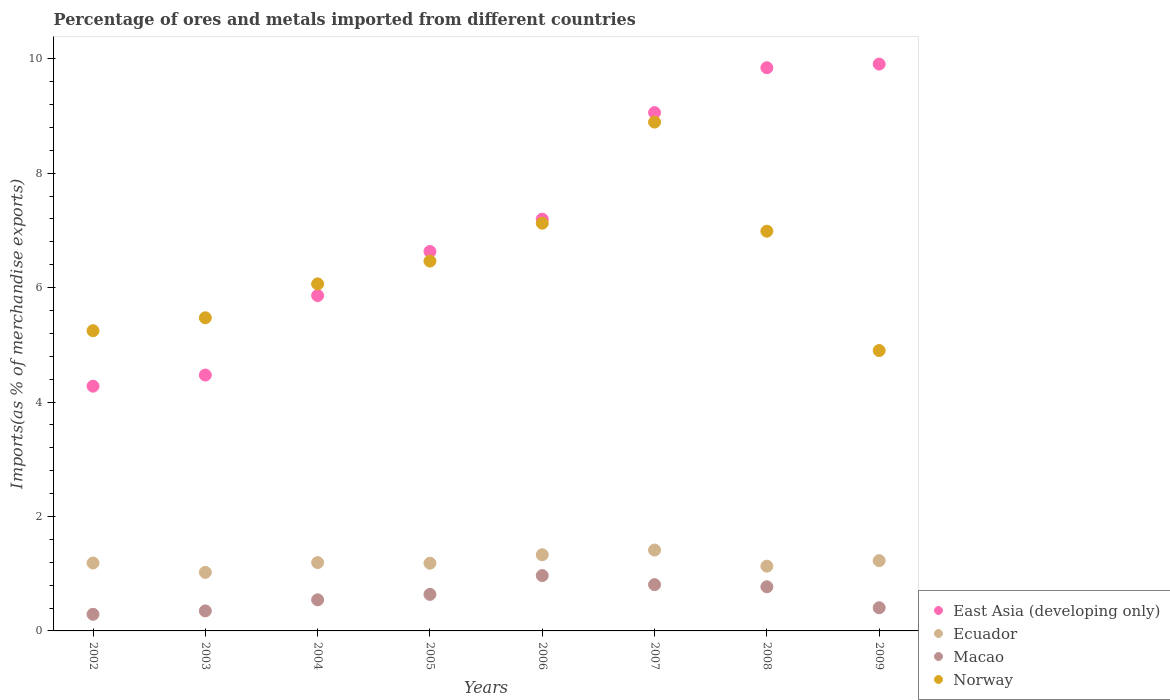Is the number of dotlines equal to the number of legend labels?
Offer a very short reply. Yes. What is the percentage of imports to different countries in East Asia (developing only) in 2009?
Keep it short and to the point. 9.91. Across all years, what is the maximum percentage of imports to different countries in East Asia (developing only)?
Your response must be concise. 9.91. Across all years, what is the minimum percentage of imports to different countries in Ecuador?
Provide a succinct answer. 1.02. What is the total percentage of imports to different countries in Macao in the graph?
Your answer should be very brief. 4.78. What is the difference between the percentage of imports to different countries in Macao in 2003 and that in 2006?
Provide a succinct answer. -0.62. What is the difference between the percentage of imports to different countries in Macao in 2005 and the percentage of imports to different countries in Ecuador in 2008?
Offer a very short reply. -0.49. What is the average percentage of imports to different countries in Ecuador per year?
Give a very brief answer. 1.21. In the year 2005, what is the difference between the percentage of imports to different countries in Norway and percentage of imports to different countries in Ecuador?
Make the answer very short. 5.28. What is the ratio of the percentage of imports to different countries in East Asia (developing only) in 2003 to that in 2006?
Offer a terse response. 0.62. Is the difference between the percentage of imports to different countries in Norway in 2003 and 2009 greater than the difference between the percentage of imports to different countries in Ecuador in 2003 and 2009?
Make the answer very short. Yes. What is the difference between the highest and the second highest percentage of imports to different countries in Ecuador?
Provide a succinct answer. 0.08. What is the difference between the highest and the lowest percentage of imports to different countries in Macao?
Your response must be concise. 0.68. In how many years, is the percentage of imports to different countries in East Asia (developing only) greater than the average percentage of imports to different countries in East Asia (developing only) taken over all years?
Make the answer very short. 4. Is the sum of the percentage of imports to different countries in Norway in 2003 and 2009 greater than the maximum percentage of imports to different countries in Macao across all years?
Provide a succinct answer. Yes. Is it the case that in every year, the sum of the percentage of imports to different countries in Ecuador and percentage of imports to different countries in East Asia (developing only)  is greater than the sum of percentage of imports to different countries in Macao and percentage of imports to different countries in Norway?
Offer a very short reply. Yes. Is it the case that in every year, the sum of the percentage of imports to different countries in East Asia (developing only) and percentage of imports to different countries in Macao  is greater than the percentage of imports to different countries in Norway?
Give a very brief answer. No. How many dotlines are there?
Your answer should be compact. 4. How many years are there in the graph?
Your answer should be compact. 8. Are the values on the major ticks of Y-axis written in scientific E-notation?
Provide a short and direct response. No. How are the legend labels stacked?
Your answer should be very brief. Vertical. What is the title of the graph?
Offer a terse response. Percentage of ores and metals imported from different countries. What is the label or title of the X-axis?
Provide a succinct answer. Years. What is the label or title of the Y-axis?
Offer a very short reply. Imports(as % of merchandise exports). What is the Imports(as % of merchandise exports) of East Asia (developing only) in 2002?
Your answer should be compact. 4.28. What is the Imports(as % of merchandise exports) in Ecuador in 2002?
Ensure brevity in your answer.  1.19. What is the Imports(as % of merchandise exports) in Macao in 2002?
Keep it short and to the point. 0.29. What is the Imports(as % of merchandise exports) in Norway in 2002?
Ensure brevity in your answer.  5.25. What is the Imports(as % of merchandise exports) in East Asia (developing only) in 2003?
Give a very brief answer. 4.47. What is the Imports(as % of merchandise exports) of Ecuador in 2003?
Make the answer very short. 1.02. What is the Imports(as % of merchandise exports) in Macao in 2003?
Your answer should be very brief. 0.35. What is the Imports(as % of merchandise exports) in Norway in 2003?
Ensure brevity in your answer.  5.47. What is the Imports(as % of merchandise exports) in East Asia (developing only) in 2004?
Your answer should be very brief. 5.86. What is the Imports(as % of merchandise exports) in Ecuador in 2004?
Offer a terse response. 1.19. What is the Imports(as % of merchandise exports) of Macao in 2004?
Your response must be concise. 0.54. What is the Imports(as % of merchandise exports) of Norway in 2004?
Offer a very short reply. 6.07. What is the Imports(as % of merchandise exports) in East Asia (developing only) in 2005?
Offer a terse response. 6.63. What is the Imports(as % of merchandise exports) of Ecuador in 2005?
Ensure brevity in your answer.  1.18. What is the Imports(as % of merchandise exports) of Macao in 2005?
Offer a very short reply. 0.64. What is the Imports(as % of merchandise exports) in Norway in 2005?
Ensure brevity in your answer.  6.46. What is the Imports(as % of merchandise exports) in East Asia (developing only) in 2006?
Make the answer very short. 7.2. What is the Imports(as % of merchandise exports) of Ecuador in 2006?
Provide a short and direct response. 1.33. What is the Imports(as % of merchandise exports) in Macao in 2006?
Your response must be concise. 0.97. What is the Imports(as % of merchandise exports) of Norway in 2006?
Give a very brief answer. 7.13. What is the Imports(as % of merchandise exports) of East Asia (developing only) in 2007?
Ensure brevity in your answer.  9.06. What is the Imports(as % of merchandise exports) of Ecuador in 2007?
Provide a short and direct response. 1.41. What is the Imports(as % of merchandise exports) of Macao in 2007?
Offer a very short reply. 0.81. What is the Imports(as % of merchandise exports) in Norway in 2007?
Make the answer very short. 8.89. What is the Imports(as % of merchandise exports) in East Asia (developing only) in 2008?
Make the answer very short. 9.84. What is the Imports(as % of merchandise exports) of Ecuador in 2008?
Your answer should be very brief. 1.13. What is the Imports(as % of merchandise exports) in Macao in 2008?
Ensure brevity in your answer.  0.77. What is the Imports(as % of merchandise exports) in Norway in 2008?
Ensure brevity in your answer.  6.99. What is the Imports(as % of merchandise exports) in East Asia (developing only) in 2009?
Your response must be concise. 9.91. What is the Imports(as % of merchandise exports) of Ecuador in 2009?
Your answer should be very brief. 1.23. What is the Imports(as % of merchandise exports) of Macao in 2009?
Provide a short and direct response. 0.4. What is the Imports(as % of merchandise exports) in Norway in 2009?
Keep it short and to the point. 4.9. Across all years, what is the maximum Imports(as % of merchandise exports) of East Asia (developing only)?
Your response must be concise. 9.91. Across all years, what is the maximum Imports(as % of merchandise exports) of Ecuador?
Provide a short and direct response. 1.41. Across all years, what is the maximum Imports(as % of merchandise exports) in Macao?
Make the answer very short. 0.97. Across all years, what is the maximum Imports(as % of merchandise exports) in Norway?
Your answer should be very brief. 8.89. Across all years, what is the minimum Imports(as % of merchandise exports) in East Asia (developing only)?
Ensure brevity in your answer.  4.28. Across all years, what is the minimum Imports(as % of merchandise exports) of Ecuador?
Keep it short and to the point. 1.02. Across all years, what is the minimum Imports(as % of merchandise exports) of Macao?
Make the answer very short. 0.29. Across all years, what is the minimum Imports(as % of merchandise exports) of Norway?
Provide a short and direct response. 4.9. What is the total Imports(as % of merchandise exports) in East Asia (developing only) in the graph?
Ensure brevity in your answer.  57.25. What is the total Imports(as % of merchandise exports) in Ecuador in the graph?
Offer a terse response. 9.69. What is the total Imports(as % of merchandise exports) in Macao in the graph?
Keep it short and to the point. 4.78. What is the total Imports(as % of merchandise exports) in Norway in the graph?
Your answer should be compact. 51.16. What is the difference between the Imports(as % of merchandise exports) of East Asia (developing only) in 2002 and that in 2003?
Your answer should be compact. -0.19. What is the difference between the Imports(as % of merchandise exports) of Ecuador in 2002 and that in 2003?
Your response must be concise. 0.16. What is the difference between the Imports(as % of merchandise exports) of Macao in 2002 and that in 2003?
Ensure brevity in your answer.  -0.06. What is the difference between the Imports(as % of merchandise exports) of Norway in 2002 and that in 2003?
Your answer should be compact. -0.23. What is the difference between the Imports(as % of merchandise exports) in East Asia (developing only) in 2002 and that in 2004?
Offer a terse response. -1.58. What is the difference between the Imports(as % of merchandise exports) of Ecuador in 2002 and that in 2004?
Give a very brief answer. -0.01. What is the difference between the Imports(as % of merchandise exports) in Macao in 2002 and that in 2004?
Offer a very short reply. -0.25. What is the difference between the Imports(as % of merchandise exports) of Norway in 2002 and that in 2004?
Your response must be concise. -0.82. What is the difference between the Imports(as % of merchandise exports) in East Asia (developing only) in 2002 and that in 2005?
Make the answer very short. -2.35. What is the difference between the Imports(as % of merchandise exports) in Ecuador in 2002 and that in 2005?
Make the answer very short. 0. What is the difference between the Imports(as % of merchandise exports) in Macao in 2002 and that in 2005?
Give a very brief answer. -0.35. What is the difference between the Imports(as % of merchandise exports) of Norway in 2002 and that in 2005?
Offer a terse response. -1.22. What is the difference between the Imports(as % of merchandise exports) of East Asia (developing only) in 2002 and that in 2006?
Your answer should be very brief. -2.92. What is the difference between the Imports(as % of merchandise exports) of Ecuador in 2002 and that in 2006?
Make the answer very short. -0.14. What is the difference between the Imports(as % of merchandise exports) of Macao in 2002 and that in 2006?
Your response must be concise. -0.68. What is the difference between the Imports(as % of merchandise exports) in Norway in 2002 and that in 2006?
Your response must be concise. -1.88. What is the difference between the Imports(as % of merchandise exports) of East Asia (developing only) in 2002 and that in 2007?
Offer a terse response. -4.78. What is the difference between the Imports(as % of merchandise exports) in Ecuador in 2002 and that in 2007?
Your response must be concise. -0.23. What is the difference between the Imports(as % of merchandise exports) in Macao in 2002 and that in 2007?
Keep it short and to the point. -0.52. What is the difference between the Imports(as % of merchandise exports) in Norway in 2002 and that in 2007?
Make the answer very short. -3.65. What is the difference between the Imports(as % of merchandise exports) of East Asia (developing only) in 2002 and that in 2008?
Provide a succinct answer. -5.57. What is the difference between the Imports(as % of merchandise exports) of Ecuador in 2002 and that in 2008?
Give a very brief answer. 0.06. What is the difference between the Imports(as % of merchandise exports) in Macao in 2002 and that in 2008?
Offer a very short reply. -0.48. What is the difference between the Imports(as % of merchandise exports) in Norway in 2002 and that in 2008?
Offer a terse response. -1.74. What is the difference between the Imports(as % of merchandise exports) in East Asia (developing only) in 2002 and that in 2009?
Your answer should be very brief. -5.63. What is the difference between the Imports(as % of merchandise exports) of Ecuador in 2002 and that in 2009?
Offer a very short reply. -0.04. What is the difference between the Imports(as % of merchandise exports) of Macao in 2002 and that in 2009?
Your response must be concise. -0.11. What is the difference between the Imports(as % of merchandise exports) of Norway in 2002 and that in 2009?
Provide a short and direct response. 0.35. What is the difference between the Imports(as % of merchandise exports) of East Asia (developing only) in 2003 and that in 2004?
Provide a succinct answer. -1.39. What is the difference between the Imports(as % of merchandise exports) in Ecuador in 2003 and that in 2004?
Provide a succinct answer. -0.17. What is the difference between the Imports(as % of merchandise exports) in Macao in 2003 and that in 2004?
Make the answer very short. -0.19. What is the difference between the Imports(as % of merchandise exports) in Norway in 2003 and that in 2004?
Your answer should be very brief. -0.59. What is the difference between the Imports(as % of merchandise exports) in East Asia (developing only) in 2003 and that in 2005?
Provide a short and direct response. -2.16. What is the difference between the Imports(as % of merchandise exports) in Ecuador in 2003 and that in 2005?
Your answer should be compact. -0.16. What is the difference between the Imports(as % of merchandise exports) in Macao in 2003 and that in 2005?
Provide a short and direct response. -0.29. What is the difference between the Imports(as % of merchandise exports) in Norway in 2003 and that in 2005?
Provide a succinct answer. -0.99. What is the difference between the Imports(as % of merchandise exports) of East Asia (developing only) in 2003 and that in 2006?
Make the answer very short. -2.72. What is the difference between the Imports(as % of merchandise exports) of Ecuador in 2003 and that in 2006?
Your answer should be compact. -0.31. What is the difference between the Imports(as % of merchandise exports) of Macao in 2003 and that in 2006?
Your answer should be compact. -0.62. What is the difference between the Imports(as % of merchandise exports) of Norway in 2003 and that in 2006?
Your answer should be compact. -1.65. What is the difference between the Imports(as % of merchandise exports) of East Asia (developing only) in 2003 and that in 2007?
Provide a succinct answer. -4.59. What is the difference between the Imports(as % of merchandise exports) of Ecuador in 2003 and that in 2007?
Your answer should be very brief. -0.39. What is the difference between the Imports(as % of merchandise exports) of Macao in 2003 and that in 2007?
Provide a short and direct response. -0.46. What is the difference between the Imports(as % of merchandise exports) in Norway in 2003 and that in 2007?
Give a very brief answer. -3.42. What is the difference between the Imports(as % of merchandise exports) in East Asia (developing only) in 2003 and that in 2008?
Offer a terse response. -5.37. What is the difference between the Imports(as % of merchandise exports) in Ecuador in 2003 and that in 2008?
Your answer should be very brief. -0.11. What is the difference between the Imports(as % of merchandise exports) in Macao in 2003 and that in 2008?
Keep it short and to the point. -0.42. What is the difference between the Imports(as % of merchandise exports) of Norway in 2003 and that in 2008?
Offer a terse response. -1.51. What is the difference between the Imports(as % of merchandise exports) in East Asia (developing only) in 2003 and that in 2009?
Offer a very short reply. -5.43. What is the difference between the Imports(as % of merchandise exports) in Ecuador in 2003 and that in 2009?
Your answer should be compact. -0.2. What is the difference between the Imports(as % of merchandise exports) in Macao in 2003 and that in 2009?
Offer a terse response. -0.06. What is the difference between the Imports(as % of merchandise exports) of Norway in 2003 and that in 2009?
Provide a succinct answer. 0.57. What is the difference between the Imports(as % of merchandise exports) in East Asia (developing only) in 2004 and that in 2005?
Give a very brief answer. -0.77. What is the difference between the Imports(as % of merchandise exports) in Ecuador in 2004 and that in 2005?
Your answer should be very brief. 0.01. What is the difference between the Imports(as % of merchandise exports) of Macao in 2004 and that in 2005?
Your answer should be very brief. -0.1. What is the difference between the Imports(as % of merchandise exports) of Norway in 2004 and that in 2005?
Give a very brief answer. -0.4. What is the difference between the Imports(as % of merchandise exports) in East Asia (developing only) in 2004 and that in 2006?
Offer a very short reply. -1.34. What is the difference between the Imports(as % of merchandise exports) in Ecuador in 2004 and that in 2006?
Offer a very short reply. -0.14. What is the difference between the Imports(as % of merchandise exports) of Macao in 2004 and that in 2006?
Make the answer very short. -0.42. What is the difference between the Imports(as % of merchandise exports) in Norway in 2004 and that in 2006?
Give a very brief answer. -1.06. What is the difference between the Imports(as % of merchandise exports) of East Asia (developing only) in 2004 and that in 2007?
Your answer should be very brief. -3.2. What is the difference between the Imports(as % of merchandise exports) in Ecuador in 2004 and that in 2007?
Your answer should be compact. -0.22. What is the difference between the Imports(as % of merchandise exports) in Macao in 2004 and that in 2007?
Offer a terse response. -0.27. What is the difference between the Imports(as % of merchandise exports) in Norway in 2004 and that in 2007?
Ensure brevity in your answer.  -2.83. What is the difference between the Imports(as % of merchandise exports) of East Asia (developing only) in 2004 and that in 2008?
Your answer should be very brief. -3.98. What is the difference between the Imports(as % of merchandise exports) of Ecuador in 2004 and that in 2008?
Provide a succinct answer. 0.06. What is the difference between the Imports(as % of merchandise exports) in Macao in 2004 and that in 2008?
Make the answer very short. -0.23. What is the difference between the Imports(as % of merchandise exports) of Norway in 2004 and that in 2008?
Ensure brevity in your answer.  -0.92. What is the difference between the Imports(as % of merchandise exports) of East Asia (developing only) in 2004 and that in 2009?
Make the answer very short. -4.05. What is the difference between the Imports(as % of merchandise exports) in Ecuador in 2004 and that in 2009?
Make the answer very short. -0.03. What is the difference between the Imports(as % of merchandise exports) in Macao in 2004 and that in 2009?
Your answer should be very brief. 0.14. What is the difference between the Imports(as % of merchandise exports) in Norway in 2004 and that in 2009?
Give a very brief answer. 1.16. What is the difference between the Imports(as % of merchandise exports) of East Asia (developing only) in 2005 and that in 2006?
Offer a very short reply. -0.56. What is the difference between the Imports(as % of merchandise exports) in Ecuador in 2005 and that in 2006?
Your answer should be compact. -0.15. What is the difference between the Imports(as % of merchandise exports) in Macao in 2005 and that in 2006?
Ensure brevity in your answer.  -0.33. What is the difference between the Imports(as % of merchandise exports) of Norway in 2005 and that in 2006?
Offer a very short reply. -0.66. What is the difference between the Imports(as % of merchandise exports) in East Asia (developing only) in 2005 and that in 2007?
Provide a succinct answer. -2.43. What is the difference between the Imports(as % of merchandise exports) in Ecuador in 2005 and that in 2007?
Offer a terse response. -0.23. What is the difference between the Imports(as % of merchandise exports) in Macao in 2005 and that in 2007?
Offer a very short reply. -0.17. What is the difference between the Imports(as % of merchandise exports) of Norway in 2005 and that in 2007?
Make the answer very short. -2.43. What is the difference between the Imports(as % of merchandise exports) in East Asia (developing only) in 2005 and that in 2008?
Make the answer very short. -3.21. What is the difference between the Imports(as % of merchandise exports) in Ecuador in 2005 and that in 2008?
Your answer should be very brief. 0.05. What is the difference between the Imports(as % of merchandise exports) in Macao in 2005 and that in 2008?
Provide a short and direct response. -0.13. What is the difference between the Imports(as % of merchandise exports) of Norway in 2005 and that in 2008?
Offer a terse response. -0.52. What is the difference between the Imports(as % of merchandise exports) in East Asia (developing only) in 2005 and that in 2009?
Your response must be concise. -3.28. What is the difference between the Imports(as % of merchandise exports) of Ecuador in 2005 and that in 2009?
Provide a succinct answer. -0.04. What is the difference between the Imports(as % of merchandise exports) of Macao in 2005 and that in 2009?
Keep it short and to the point. 0.23. What is the difference between the Imports(as % of merchandise exports) in Norway in 2005 and that in 2009?
Give a very brief answer. 1.56. What is the difference between the Imports(as % of merchandise exports) of East Asia (developing only) in 2006 and that in 2007?
Keep it short and to the point. -1.86. What is the difference between the Imports(as % of merchandise exports) in Ecuador in 2006 and that in 2007?
Provide a succinct answer. -0.08. What is the difference between the Imports(as % of merchandise exports) in Macao in 2006 and that in 2007?
Your answer should be compact. 0.16. What is the difference between the Imports(as % of merchandise exports) in Norway in 2006 and that in 2007?
Offer a terse response. -1.77. What is the difference between the Imports(as % of merchandise exports) in East Asia (developing only) in 2006 and that in 2008?
Give a very brief answer. -2.65. What is the difference between the Imports(as % of merchandise exports) in Ecuador in 2006 and that in 2008?
Your answer should be very brief. 0.2. What is the difference between the Imports(as % of merchandise exports) in Macao in 2006 and that in 2008?
Offer a terse response. 0.2. What is the difference between the Imports(as % of merchandise exports) in Norway in 2006 and that in 2008?
Your response must be concise. 0.14. What is the difference between the Imports(as % of merchandise exports) in East Asia (developing only) in 2006 and that in 2009?
Provide a short and direct response. -2.71. What is the difference between the Imports(as % of merchandise exports) in Ecuador in 2006 and that in 2009?
Your answer should be very brief. 0.1. What is the difference between the Imports(as % of merchandise exports) of Macao in 2006 and that in 2009?
Provide a short and direct response. 0.56. What is the difference between the Imports(as % of merchandise exports) of Norway in 2006 and that in 2009?
Ensure brevity in your answer.  2.23. What is the difference between the Imports(as % of merchandise exports) in East Asia (developing only) in 2007 and that in 2008?
Provide a short and direct response. -0.78. What is the difference between the Imports(as % of merchandise exports) in Ecuador in 2007 and that in 2008?
Make the answer very short. 0.28. What is the difference between the Imports(as % of merchandise exports) of Macao in 2007 and that in 2008?
Your answer should be compact. 0.04. What is the difference between the Imports(as % of merchandise exports) of Norway in 2007 and that in 2008?
Offer a very short reply. 1.91. What is the difference between the Imports(as % of merchandise exports) in East Asia (developing only) in 2007 and that in 2009?
Your answer should be compact. -0.85. What is the difference between the Imports(as % of merchandise exports) in Ecuador in 2007 and that in 2009?
Offer a very short reply. 0.19. What is the difference between the Imports(as % of merchandise exports) of Macao in 2007 and that in 2009?
Your answer should be compact. 0.4. What is the difference between the Imports(as % of merchandise exports) of Norway in 2007 and that in 2009?
Provide a succinct answer. 3.99. What is the difference between the Imports(as % of merchandise exports) of East Asia (developing only) in 2008 and that in 2009?
Offer a very short reply. -0.06. What is the difference between the Imports(as % of merchandise exports) in Ecuador in 2008 and that in 2009?
Provide a succinct answer. -0.1. What is the difference between the Imports(as % of merchandise exports) in Macao in 2008 and that in 2009?
Your answer should be compact. 0.37. What is the difference between the Imports(as % of merchandise exports) in Norway in 2008 and that in 2009?
Offer a very short reply. 2.09. What is the difference between the Imports(as % of merchandise exports) of East Asia (developing only) in 2002 and the Imports(as % of merchandise exports) of Ecuador in 2003?
Give a very brief answer. 3.25. What is the difference between the Imports(as % of merchandise exports) of East Asia (developing only) in 2002 and the Imports(as % of merchandise exports) of Macao in 2003?
Give a very brief answer. 3.93. What is the difference between the Imports(as % of merchandise exports) in East Asia (developing only) in 2002 and the Imports(as % of merchandise exports) in Norway in 2003?
Offer a very short reply. -1.2. What is the difference between the Imports(as % of merchandise exports) in Ecuador in 2002 and the Imports(as % of merchandise exports) in Macao in 2003?
Give a very brief answer. 0.84. What is the difference between the Imports(as % of merchandise exports) of Ecuador in 2002 and the Imports(as % of merchandise exports) of Norway in 2003?
Your answer should be very brief. -4.29. What is the difference between the Imports(as % of merchandise exports) of Macao in 2002 and the Imports(as % of merchandise exports) of Norway in 2003?
Offer a very short reply. -5.18. What is the difference between the Imports(as % of merchandise exports) in East Asia (developing only) in 2002 and the Imports(as % of merchandise exports) in Ecuador in 2004?
Your response must be concise. 3.08. What is the difference between the Imports(as % of merchandise exports) in East Asia (developing only) in 2002 and the Imports(as % of merchandise exports) in Macao in 2004?
Make the answer very short. 3.73. What is the difference between the Imports(as % of merchandise exports) in East Asia (developing only) in 2002 and the Imports(as % of merchandise exports) in Norway in 2004?
Make the answer very short. -1.79. What is the difference between the Imports(as % of merchandise exports) in Ecuador in 2002 and the Imports(as % of merchandise exports) in Macao in 2004?
Provide a short and direct response. 0.64. What is the difference between the Imports(as % of merchandise exports) in Ecuador in 2002 and the Imports(as % of merchandise exports) in Norway in 2004?
Provide a short and direct response. -4.88. What is the difference between the Imports(as % of merchandise exports) in Macao in 2002 and the Imports(as % of merchandise exports) in Norway in 2004?
Keep it short and to the point. -5.77. What is the difference between the Imports(as % of merchandise exports) of East Asia (developing only) in 2002 and the Imports(as % of merchandise exports) of Ecuador in 2005?
Your answer should be very brief. 3.09. What is the difference between the Imports(as % of merchandise exports) in East Asia (developing only) in 2002 and the Imports(as % of merchandise exports) in Macao in 2005?
Your answer should be compact. 3.64. What is the difference between the Imports(as % of merchandise exports) of East Asia (developing only) in 2002 and the Imports(as % of merchandise exports) of Norway in 2005?
Your answer should be very brief. -2.19. What is the difference between the Imports(as % of merchandise exports) of Ecuador in 2002 and the Imports(as % of merchandise exports) of Macao in 2005?
Provide a short and direct response. 0.55. What is the difference between the Imports(as % of merchandise exports) of Ecuador in 2002 and the Imports(as % of merchandise exports) of Norway in 2005?
Make the answer very short. -5.28. What is the difference between the Imports(as % of merchandise exports) of Macao in 2002 and the Imports(as % of merchandise exports) of Norway in 2005?
Provide a short and direct response. -6.17. What is the difference between the Imports(as % of merchandise exports) in East Asia (developing only) in 2002 and the Imports(as % of merchandise exports) in Ecuador in 2006?
Your answer should be compact. 2.95. What is the difference between the Imports(as % of merchandise exports) in East Asia (developing only) in 2002 and the Imports(as % of merchandise exports) in Macao in 2006?
Offer a very short reply. 3.31. What is the difference between the Imports(as % of merchandise exports) in East Asia (developing only) in 2002 and the Imports(as % of merchandise exports) in Norway in 2006?
Provide a succinct answer. -2.85. What is the difference between the Imports(as % of merchandise exports) of Ecuador in 2002 and the Imports(as % of merchandise exports) of Macao in 2006?
Your answer should be very brief. 0.22. What is the difference between the Imports(as % of merchandise exports) in Ecuador in 2002 and the Imports(as % of merchandise exports) in Norway in 2006?
Ensure brevity in your answer.  -5.94. What is the difference between the Imports(as % of merchandise exports) of Macao in 2002 and the Imports(as % of merchandise exports) of Norway in 2006?
Provide a short and direct response. -6.84. What is the difference between the Imports(as % of merchandise exports) in East Asia (developing only) in 2002 and the Imports(as % of merchandise exports) in Ecuador in 2007?
Ensure brevity in your answer.  2.86. What is the difference between the Imports(as % of merchandise exports) of East Asia (developing only) in 2002 and the Imports(as % of merchandise exports) of Macao in 2007?
Your answer should be very brief. 3.47. What is the difference between the Imports(as % of merchandise exports) of East Asia (developing only) in 2002 and the Imports(as % of merchandise exports) of Norway in 2007?
Keep it short and to the point. -4.62. What is the difference between the Imports(as % of merchandise exports) of Ecuador in 2002 and the Imports(as % of merchandise exports) of Macao in 2007?
Offer a terse response. 0.38. What is the difference between the Imports(as % of merchandise exports) of Ecuador in 2002 and the Imports(as % of merchandise exports) of Norway in 2007?
Keep it short and to the point. -7.71. What is the difference between the Imports(as % of merchandise exports) of Macao in 2002 and the Imports(as % of merchandise exports) of Norway in 2007?
Your answer should be compact. -8.6. What is the difference between the Imports(as % of merchandise exports) of East Asia (developing only) in 2002 and the Imports(as % of merchandise exports) of Ecuador in 2008?
Offer a terse response. 3.15. What is the difference between the Imports(as % of merchandise exports) in East Asia (developing only) in 2002 and the Imports(as % of merchandise exports) in Macao in 2008?
Make the answer very short. 3.51. What is the difference between the Imports(as % of merchandise exports) of East Asia (developing only) in 2002 and the Imports(as % of merchandise exports) of Norway in 2008?
Provide a short and direct response. -2.71. What is the difference between the Imports(as % of merchandise exports) in Ecuador in 2002 and the Imports(as % of merchandise exports) in Macao in 2008?
Keep it short and to the point. 0.42. What is the difference between the Imports(as % of merchandise exports) in Ecuador in 2002 and the Imports(as % of merchandise exports) in Norway in 2008?
Your answer should be very brief. -5.8. What is the difference between the Imports(as % of merchandise exports) in Macao in 2002 and the Imports(as % of merchandise exports) in Norway in 2008?
Make the answer very short. -6.7. What is the difference between the Imports(as % of merchandise exports) in East Asia (developing only) in 2002 and the Imports(as % of merchandise exports) in Ecuador in 2009?
Your answer should be very brief. 3.05. What is the difference between the Imports(as % of merchandise exports) of East Asia (developing only) in 2002 and the Imports(as % of merchandise exports) of Macao in 2009?
Your answer should be compact. 3.87. What is the difference between the Imports(as % of merchandise exports) of East Asia (developing only) in 2002 and the Imports(as % of merchandise exports) of Norway in 2009?
Your answer should be compact. -0.62. What is the difference between the Imports(as % of merchandise exports) in Ecuador in 2002 and the Imports(as % of merchandise exports) in Macao in 2009?
Provide a succinct answer. 0.78. What is the difference between the Imports(as % of merchandise exports) of Ecuador in 2002 and the Imports(as % of merchandise exports) of Norway in 2009?
Ensure brevity in your answer.  -3.71. What is the difference between the Imports(as % of merchandise exports) in Macao in 2002 and the Imports(as % of merchandise exports) in Norway in 2009?
Offer a very short reply. -4.61. What is the difference between the Imports(as % of merchandise exports) of East Asia (developing only) in 2003 and the Imports(as % of merchandise exports) of Ecuador in 2004?
Give a very brief answer. 3.28. What is the difference between the Imports(as % of merchandise exports) in East Asia (developing only) in 2003 and the Imports(as % of merchandise exports) in Macao in 2004?
Keep it short and to the point. 3.93. What is the difference between the Imports(as % of merchandise exports) in East Asia (developing only) in 2003 and the Imports(as % of merchandise exports) in Norway in 2004?
Give a very brief answer. -1.59. What is the difference between the Imports(as % of merchandise exports) in Ecuador in 2003 and the Imports(as % of merchandise exports) in Macao in 2004?
Your answer should be compact. 0.48. What is the difference between the Imports(as % of merchandise exports) in Ecuador in 2003 and the Imports(as % of merchandise exports) in Norway in 2004?
Offer a terse response. -5.04. What is the difference between the Imports(as % of merchandise exports) of Macao in 2003 and the Imports(as % of merchandise exports) of Norway in 2004?
Provide a short and direct response. -5.72. What is the difference between the Imports(as % of merchandise exports) in East Asia (developing only) in 2003 and the Imports(as % of merchandise exports) in Ecuador in 2005?
Keep it short and to the point. 3.29. What is the difference between the Imports(as % of merchandise exports) of East Asia (developing only) in 2003 and the Imports(as % of merchandise exports) of Macao in 2005?
Make the answer very short. 3.83. What is the difference between the Imports(as % of merchandise exports) of East Asia (developing only) in 2003 and the Imports(as % of merchandise exports) of Norway in 2005?
Provide a succinct answer. -1.99. What is the difference between the Imports(as % of merchandise exports) of Ecuador in 2003 and the Imports(as % of merchandise exports) of Macao in 2005?
Give a very brief answer. 0.38. What is the difference between the Imports(as % of merchandise exports) of Ecuador in 2003 and the Imports(as % of merchandise exports) of Norway in 2005?
Provide a short and direct response. -5.44. What is the difference between the Imports(as % of merchandise exports) in Macao in 2003 and the Imports(as % of merchandise exports) in Norway in 2005?
Your answer should be compact. -6.11. What is the difference between the Imports(as % of merchandise exports) of East Asia (developing only) in 2003 and the Imports(as % of merchandise exports) of Ecuador in 2006?
Your answer should be compact. 3.14. What is the difference between the Imports(as % of merchandise exports) in East Asia (developing only) in 2003 and the Imports(as % of merchandise exports) in Macao in 2006?
Ensure brevity in your answer.  3.5. What is the difference between the Imports(as % of merchandise exports) in East Asia (developing only) in 2003 and the Imports(as % of merchandise exports) in Norway in 2006?
Your answer should be compact. -2.65. What is the difference between the Imports(as % of merchandise exports) in Ecuador in 2003 and the Imports(as % of merchandise exports) in Macao in 2006?
Keep it short and to the point. 0.06. What is the difference between the Imports(as % of merchandise exports) in Ecuador in 2003 and the Imports(as % of merchandise exports) in Norway in 2006?
Make the answer very short. -6.1. What is the difference between the Imports(as % of merchandise exports) in Macao in 2003 and the Imports(as % of merchandise exports) in Norway in 2006?
Keep it short and to the point. -6.78. What is the difference between the Imports(as % of merchandise exports) of East Asia (developing only) in 2003 and the Imports(as % of merchandise exports) of Ecuador in 2007?
Offer a terse response. 3.06. What is the difference between the Imports(as % of merchandise exports) of East Asia (developing only) in 2003 and the Imports(as % of merchandise exports) of Macao in 2007?
Provide a succinct answer. 3.66. What is the difference between the Imports(as % of merchandise exports) in East Asia (developing only) in 2003 and the Imports(as % of merchandise exports) in Norway in 2007?
Ensure brevity in your answer.  -4.42. What is the difference between the Imports(as % of merchandise exports) in Ecuador in 2003 and the Imports(as % of merchandise exports) in Macao in 2007?
Your answer should be compact. 0.21. What is the difference between the Imports(as % of merchandise exports) in Ecuador in 2003 and the Imports(as % of merchandise exports) in Norway in 2007?
Provide a short and direct response. -7.87. What is the difference between the Imports(as % of merchandise exports) in Macao in 2003 and the Imports(as % of merchandise exports) in Norway in 2007?
Ensure brevity in your answer.  -8.54. What is the difference between the Imports(as % of merchandise exports) in East Asia (developing only) in 2003 and the Imports(as % of merchandise exports) in Ecuador in 2008?
Offer a very short reply. 3.34. What is the difference between the Imports(as % of merchandise exports) of East Asia (developing only) in 2003 and the Imports(as % of merchandise exports) of Macao in 2008?
Offer a very short reply. 3.7. What is the difference between the Imports(as % of merchandise exports) of East Asia (developing only) in 2003 and the Imports(as % of merchandise exports) of Norway in 2008?
Offer a very short reply. -2.51. What is the difference between the Imports(as % of merchandise exports) in Ecuador in 2003 and the Imports(as % of merchandise exports) in Macao in 2008?
Your response must be concise. 0.25. What is the difference between the Imports(as % of merchandise exports) in Ecuador in 2003 and the Imports(as % of merchandise exports) in Norway in 2008?
Keep it short and to the point. -5.96. What is the difference between the Imports(as % of merchandise exports) of Macao in 2003 and the Imports(as % of merchandise exports) of Norway in 2008?
Your answer should be compact. -6.64. What is the difference between the Imports(as % of merchandise exports) in East Asia (developing only) in 2003 and the Imports(as % of merchandise exports) in Ecuador in 2009?
Ensure brevity in your answer.  3.24. What is the difference between the Imports(as % of merchandise exports) in East Asia (developing only) in 2003 and the Imports(as % of merchandise exports) in Macao in 2009?
Offer a very short reply. 4.07. What is the difference between the Imports(as % of merchandise exports) in East Asia (developing only) in 2003 and the Imports(as % of merchandise exports) in Norway in 2009?
Provide a short and direct response. -0.43. What is the difference between the Imports(as % of merchandise exports) in Ecuador in 2003 and the Imports(as % of merchandise exports) in Macao in 2009?
Ensure brevity in your answer.  0.62. What is the difference between the Imports(as % of merchandise exports) of Ecuador in 2003 and the Imports(as % of merchandise exports) of Norway in 2009?
Offer a terse response. -3.88. What is the difference between the Imports(as % of merchandise exports) in Macao in 2003 and the Imports(as % of merchandise exports) in Norway in 2009?
Your answer should be very brief. -4.55. What is the difference between the Imports(as % of merchandise exports) in East Asia (developing only) in 2004 and the Imports(as % of merchandise exports) in Ecuador in 2005?
Offer a terse response. 4.68. What is the difference between the Imports(as % of merchandise exports) in East Asia (developing only) in 2004 and the Imports(as % of merchandise exports) in Macao in 2005?
Ensure brevity in your answer.  5.22. What is the difference between the Imports(as % of merchandise exports) of East Asia (developing only) in 2004 and the Imports(as % of merchandise exports) of Norway in 2005?
Offer a terse response. -0.6. What is the difference between the Imports(as % of merchandise exports) of Ecuador in 2004 and the Imports(as % of merchandise exports) of Macao in 2005?
Offer a terse response. 0.56. What is the difference between the Imports(as % of merchandise exports) in Ecuador in 2004 and the Imports(as % of merchandise exports) in Norway in 2005?
Your answer should be very brief. -5.27. What is the difference between the Imports(as % of merchandise exports) of Macao in 2004 and the Imports(as % of merchandise exports) of Norway in 2005?
Keep it short and to the point. -5.92. What is the difference between the Imports(as % of merchandise exports) of East Asia (developing only) in 2004 and the Imports(as % of merchandise exports) of Ecuador in 2006?
Offer a terse response. 4.53. What is the difference between the Imports(as % of merchandise exports) of East Asia (developing only) in 2004 and the Imports(as % of merchandise exports) of Macao in 2006?
Provide a short and direct response. 4.89. What is the difference between the Imports(as % of merchandise exports) of East Asia (developing only) in 2004 and the Imports(as % of merchandise exports) of Norway in 2006?
Offer a very short reply. -1.27. What is the difference between the Imports(as % of merchandise exports) of Ecuador in 2004 and the Imports(as % of merchandise exports) of Macao in 2006?
Your response must be concise. 0.23. What is the difference between the Imports(as % of merchandise exports) of Ecuador in 2004 and the Imports(as % of merchandise exports) of Norway in 2006?
Ensure brevity in your answer.  -5.93. What is the difference between the Imports(as % of merchandise exports) in Macao in 2004 and the Imports(as % of merchandise exports) in Norway in 2006?
Your response must be concise. -6.58. What is the difference between the Imports(as % of merchandise exports) of East Asia (developing only) in 2004 and the Imports(as % of merchandise exports) of Ecuador in 2007?
Your answer should be compact. 4.45. What is the difference between the Imports(as % of merchandise exports) in East Asia (developing only) in 2004 and the Imports(as % of merchandise exports) in Macao in 2007?
Ensure brevity in your answer.  5.05. What is the difference between the Imports(as % of merchandise exports) in East Asia (developing only) in 2004 and the Imports(as % of merchandise exports) in Norway in 2007?
Offer a very short reply. -3.03. What is the difference between the Imports(as % of merchandise exports) in Ecuador in 2004 and the Imports(as % of merchandise exports) in Macao in 2007?
Your answer should be very brief. 0.39. What is the difference between the Imports(as % of merchandise exports) of Ecuador in 2004 and the Imports(as % of merchandise exports) of Norway in 2007?
Your answer should be compact. -7.7. What is the difference between the Imports(as % of merchandise exports) of Macao in 2004 and the Imports(as % of merchandise exports) of Norway in 2007?
Make the answer very short. -8.35. What is the difference between the Imports(as % of merchandise exports) of East Asia (developing only) in 2004 and the Imports(as % of merchandise exports) of Ecuador in 2008?
Your answer should be compact. 4.73. What is the difference between the Imports(as % of merchandise exports) in East Asia (developing only) in 2004 and the Imports(as % of merchandise exports) in Macao in 2008?
Your answer should be very brief. 5.09. What is the difference between the Imports(as % of merchandise exports) of East Asia (developing only) in 2004 and the Imports(as % of merchandise exports) of Norway in 2008?
Provide a succinct answer. -1.13. What is the difference between the Imports(as % of merchandise exports) in Ecuador in 2004 and the Imports(as % of merchandise exports) in Macao in 2008?
Keep it short and to the point. 0.42. What is the difference between the Imports(as % of merchandise exports) in Ecuador in 2004 and the Imports(as % of merchandise exports) in Norway in 2008?
Offer a terse response. -5.79. What is the difference between the Imports(as % of merchandise exports) in Macao in 2004 and the Imports(as % of merchandise exports) in Norway in 2008?
Give a very brief answer. -6.44. What is the difference between the Imports(as % of merchandise exports) of East Asia (developing only) in 2004 and the Imports(as % of merchandise exports) of Ecuador in 2009?
Provide a short and direct response. 4.63. What is the difference between the Imports(as % of merchandise exports) of East Asia (developing only) in 2004 and the Imports(as % of merchandise exports) of Macao in 2009?
Keep it short and to the point. 5.46. What is the difference between the Imports(as % of merchandise exports) in East Asia (developing only) in 2004 and the Imports(as % of merchandise exports) in Norway in 2009?
Your response must be concise. 0.96. What is the difference between the Imports(as % of merchandise exports) in Ecuador in 2004 and the Imports(as % of merchandise exports) in Macao in 2009?
Give a very brief answer. 0.79. What is the difference between the Imports(as % of merchandise exports) of Ecuador in 2004 and the Imports(as % of merchandise exports) of Norway in 2009?
Offer a terse response. -3.71. What is the difference between the Imports(as % of merchandise exports) of Macao in 2004 and the Imports(as % of merchandise exports) of Norway in 2009?
Your answer should be compact. -4.36. What is the difference between the Imports(as % of merchandise exports) in East Asia (developing only) in 2005 and the Imports(as % of merchandise exports) in Ecuador in 2006?
Your response must be concise. 5.3. What is the difference between the Imports(as % of merchandise exports) of East Asia (developing only) in 2005 and the Imports(as % of merchandise exports) of Macao in 2006?
Give a very brief answer. 5.66. What is the difference between the Imports(as % of merchandise exports) in East Asia (developing only) in 2005 and the Imports(as % of merchandise exports) in Norway in 2006?
Offer a terse response. -0.49. What is the difference between the Imports(as % of merchandise exports) of Ecuador in 2005 and the Imports(as % of merchandise exports) of Macao in 2006?
Offer a terse response. 0.22. What is the difference between the Imports(as % of merchandise exports) in Ecuador in 2005 and the Imports(as % of merchandise exports) in Norway in 2006?
Ensure brevity in your answer.  -5.94. What is the difference between the Imports(as % of merchandise exports) in Macao in 2005 and the Imports(as % of merchandise exports) in Norway in 2006?
Offer a terse response. -6.49. What is the difference between the Imports(as % of merchandise exports) of East Asia (developing only) in 2005 and the Imports(as % of merchandise exports) of Ecuador in 2007?
Your answer should be very brief. 5.22. What is the difference between the Imports(as % of merchandise exports) of East Asia (developing only) in 2005 and the Imports(as % of merchandise exports) of Macao in 2007?
Give a very brief answer. 5.82. What is the difference between the Imports(as % of merchandise exports) of East Asia (developing only) in 2005 and the Imports(as % of merchandise exports) of Norway in 2007?
Your response must be concise. -2.26. What is the difference between the Imports(as % of merchandise exports) of Ecuador in 2005 and the Imports(as % of merchandise exports) of Macao in 2007?
Your response must be concise. 0.37. What is the difference between the Imports(as % of merchandise exports) in Ecuador in 2005 and the Imports(as % of merchandise exports) in Norway in 2007?
Make the answer very short. -7.71. What is the difference between the Imports(as % of merchandise exports) of Macao in 2005 and the Imports(as % of merchandise exports) of Norway in 2007?
Your response must be concise. -8.25. What is the difference between the Imports(as % of merchandise exports) in East Asia (developing only) in 2005 and the Imports(as % of merchandise exports) in Ecuador in 2008?
Provide a succinct answer. 5.5. What is the difference between the Imports(as % of merchandise exports) of East Asia (developing only) in 2005 and the Imports(as % of merchandise exports) of Macao in 2008?
Your answer should be very brief. 5.86. What is the difference between the Imports(as % of merchandise exports) in East Asia (developing only) in 2005 and the Imports(as % of merchandise exports) in Norway in 2008?
Your answer should be compact. -0.35. What is the difference between the Imports(as % of merchandise exports) of Ecuador in 2005 and the Imports(as % of merchandise exports) of Macao in 2008?
Provide a short and direct response. 0.41. What is the difference between the Imports(as % of merchandise exports) of Ecuador in 2005 and the Imports(as % of merchandise exports) of Norway in 2008?
Provide a short and direct response. -5.8. What is the difference between the Imports(as % of merchandise exports) of Macao in 2005 and the Imports(as % of merchandise exports) of Norway in 2008?
Your response must be concise. -6.35. What is the difference between the Imports(as % of merchandise exports) of East Asia (developing only) in 2005 and the Imports(as % of merchandise exports) of Ecuador in 2009?
Your answer should be very brief. 5.4. What is the difference between the Imports(as % of merchandise exports) of East Asia (developing only) in 2005 and the Imports(as % of merchandise exports) of Macao in 2009?
Your answer should be very brief. 6.23. What is the difference between the Imports(as % of merchandise exports) in East Asia (developing only) in 2005 and the Imports(as % of merchandise exports) in Norway in 2009?
Provide a succinct answer. 1.73. What is the difference between the Imports(as % of merchandise exports) of Ecuador in 2005 and the Imports(as % of merchandise exports) of Macao in 2009?
Provide a short and direct response. 0.78. What is the difference between the Imports(as % of merchandise exports) of Ecuador in 2005 and the Imports(as % of merchandise exports) of Norway in 2009?
Provide a succinct answer. -3.72. What is the difference between the Imports(as % of merchandise exports) of Macao in 2005 and the Imports(as % of merchandise exports) of Norway in 2009?
Offer a very short reply. -4.26. What is the difference between the Imports(as % of merchandise exports) of East Asia (developing only) in 2006 and the Imports(as % of merchandise exports) of Ecuador in 2007?
Your response must be concise. 5.78. What is the difference between the Imports(as % of merchandise exports) in East Asia (developing only) in 2006 and the Imports(as % of merchandise exports) in Macao in 2007?
Ensure brevity in your answer.  6.39. What is the difference between the Imports(as % of merchandise exports) of East Asia (developing only) in 2006 and the Imports(as % of merchandise exports) of Norway in 2007?
Give a very brief answer. -1.7. What is the difference between the Imports(as % of merchandise exports) of Ecuador in 2006 and the Imports(as % of merchandise exports) of Macao in 2007?
Keep it short and to the point. 0.52. What is the difference between the Imports(as % of merchandise exports) in Ecuador in 2006 and the Imports(as % of merchandise exports) in Norway in 2007?
Provide a succinct answer. -7.56. What is the difference between the Imports(as % of merchandise exports) of Macao in 2006 and the Imports(as % of merchandise exports) of Norway in 2007?
Ensure brevity in your answer.  -7.93. What is the difference between the Imports(as % of merchandise exports) of East Asia (developing only) in 2006 and the Imports(as % of merchandise exports) of Ecuador in 2008?
Your response must be concise. 6.06. What is the difference between the Imports(as % of merchandise exports) of East Asia (developing only) in 2006 and the Imports(as % of merchandise exports) of Macao in 2008?
Provide a short and direct response. 6.42. What is the difference between the Imports(as % of merchandise exports) of East Asia (developing only) in 2006 and the Imports(as % of merchandise exports) of Norway in 2008?
Offer a terse response. 0.21. What is the difference between the Imports(as % of merchandise exports) of Ecuador in 2006 and the Imports(as % of merchandise exports) of Macao in 2008?
Your response must be concise. 0.56. What is the difference between the Imports(as % of merchandise exports) of Ecuador in 2006 and the Imports(as % of merchandise exports) of Norway in 2008?
Make the answer very short. -5.66. What is the difference between the Imports(as % of merchandise exports) in Macao in 2006 and the Imports(as % of merchandise exports) in Norway in 2008?
Your response must be concise. -6.02. What is the difference between the Imports(as % of merchandise exports) in East Asia (developing only) in 2006 and the Imports(as % of merchandise exports) in Ecuador in 2009?
Give a very brief answer. 5.97. What is the difference between the Imports(as % of merchandise exports) in East Asia (developing only) in 2006 and the Imports(as % of merchandise exports) in Macao in 2009?
Offer a terse response. 6.79. What is the difference between the Imports(as % of merchandise exports) in East Asia (developing only) in 2006 and the Imports(as % of merchandise exports) in Norway in 2009?
Offer a very short reply. 2.3. What is the difference between the Imports(as % of merchandise exports) of Ecuador in 2006 and the Imports(as % of merchandise exports) of Macao in 2009?
Provide a short and direct response. 0.93. What is the difference between the Imports(as % of merchandise exports) of Ecuador in 2006 and the Imports(as % of merchandise exports) of Norway in 2009?
Offer a very short reply. -3.57. What is the difference between the Imports(as % of merchandise exports) of Macao in 2006 and the Imports(as % of merchandise exports) of Norway in 2009?
Provide a succinct answer. -3.93. What is the difference between the Imports(as % of merchandise exports) in East Asia (developing only) in 2007 and the Imports(as % of merchandise exports) in Ecuador in 2008?
Offer a terse response. 7.93. What is the difference between the Imports(as % of merchandise exports) in East Asia (developing only) in 2007 and the Imports(as % of merchandise exports) in Macao in 2008?
Provide a short and direct response. 8.29. What is the difference between the Imports(as % of merchandise exports) of East Asia (developing only) in 2007 and the Imports(as % of merchandise exports) of Norway in 2008?
Offer a terse response. 2.07. What is the difference between the Imports(as % of merchandise exports) in Ecuador in 2007 and the Imports(as % of merchandise exports) in Macao in 2008?
Provide a succinct answer. 0.64. What is the difference between the Imports(as % of merchandise exports) in Ecuador in 2007 and the Imports(as % of merchandise exports) in Norway in 2008?
Give a very brief answer. -5.57. What is the difference between the Imports(as % of merchandise exports) of Macao in 2007 and the Imports(as % of merchandise exports) of Norway in 2008?
Give a very brief answer. -6.18. What is the difference between the Imports(as % of merchandise exports) of East Asia (developing only) in 2007 and the Imports(as % of merchandise exports) of Ecuador in 2009?
Your response must be concise. 7.83. What is the difference between the Imports(as % of merchandise exports) of East Asia (developing only) in 2007 and the Imports(as % of merchandise exports) of Macao in 2009?
Offer a terse response. 8.65. What is the difference between the Imports(as % of merchandise exports) of East Asia (developing only) in 2007 and the Imports(as % of merchandise exports) of Norway in 2009?
Offer a very short reply. 4.16. What is the difference between the Imports(as % of merchandise exports) in Ecuador in 2007 and the Imports(as % of merchandise exports) in Macao in 2009?
Ensure brevity in your answer.  1.01. What is the difference between the Imports(as % of merchandise exports) of Ecuador in 2007 and the Imports(as % of merchandise exports) of Norway in 2009?
Offer a very short reply. -3.49. What is the difference between the Imports(as % of merchandise exports) of Macao in 2007 and the Imports(as % of merchandise exports) of Norway in 2009?
Your answer should be very brief. -4.09. What is the difference between the Imports(as % of merchandise exports) of East Asia (developing only) in 2008 and the Imports(as % of merchandise exports) of Ecuador in 2009?
Keep it short and to the point. 8.62. What is the difference between the Imports(as % of merchandise exports) in East Asia (developing only) in 2008 and the Imports(as % of merchandise exports) in Macao in 2009?
Ensure brevity in your answer.  9.44. What is the difference between the Imports(as % of merchandise exports) in East Asia (developing only) in 2008 and the Imports(as % of merchandise exports) in Norway in 2009?
Give a very brief answer. 4.94. What is the difference between the Imports(as % of merchandise exports) in Ecuador in 2008 and the Imports(as % of merchandise exports) in Macao in 2009?
Your response must be concise. 0.73. What is the difference between the Imports(as % of merchandise exports) of Ecuador in 2008 and the Imports(as % of merchandise exports) of Norway in 2009?
Provide a short and direct response. -3.77. What is the difference between the Imports(as % of merchandise exports) in Macao in 2008 and the Imports(as % of merchandise exports) in Norway in 2009?
Your response must be concise. -4.13. What is the average Imports(as % of merchandise exports) of East Asia (developing only) per year?
Provide a short and direct response. 7.16. What is the average Imports(as % of merchandise exports) of Ecuador per year?
Ensure brevity in your answer.  1.21. What is the average Imports(as % of merchandise exports) in Macao per year?
Make the answer very short. 0.6. What is the average Imports(as % of merchandise exports) in Norway per year?
Offer a very short reply. 6.39. In the year 2002, what is the difference between the Imports(as % of merchandise exports) in East Asia (developing only) and Imports(as % of merchandise exports) in Ecuador?
Your answer should be compact. 3.09. In the year 2002, what is the difference between the Imports(as % of merchandise exports) in East Asia (developing only) and Imports(as % of merchandise exports) in Macao?
Provide a short and direct response. 3.99. In the year 2002, what is the difference between the Imports(as % of merchandise exports) of East Asia (developing only) and Imports(as % of merchandise exports) of Norway?
Offer a terse response. -0.97. In the year 2002, what is the difference between the Imports(as % of merchandise exports) in Ecuador and Imports(as % of merchandise exports) in Macao?
Your response must be concise. 0.9. In the year 2002, what is the difference between the Imports(as % of merchandise exports) of Ecuador and Imports(as % of merchandise exports) of Norway?
Make the answer very short. -4.06. In the year 2002, what is the difference between the Imports(as % of merchandise exports) of Macao and Imports(as % of merchandise exports) of Norway?
Provide a succinct answer. -4.96. In the year 2003, what is the difference between the Imports(as % of merchandise exports) of East Asia (developing only) and Imports(as % of merchandise exports) of Ecuador?
Ensure brevity in your answer.  3.45. In the year 2003, what is the difference between the Imports(as % of merchandise exports) in East Asia (developing only) and Imports(as % of merchandise exports) in Macao?
Provide a short and direct response. 4.12. In the year 2003, what is the difference between the Imports(as % of merchandise exports) in East Asia (developing only) and Imports(as % of merchandise exports) in Norway?
Make the answer very short. -1. In the year 2003, what is the difference between the Imports(as % of merchandise exports) of Ecuador and Imports(as % of merchandise exports) of Macao?
Provide a short and direct response. 0.67. In the year 2003, what is the difference between the Imports(as % of merchandise exports) of Ecuador and Imports(as % of merchandise exports) of Norway?
Provide a short and direct response. -4.45. In the year 2003, what is the difference between the Imports(as % of merchandise exports) in Macao and Imports(as % of merchandise exports) in Norway?
Keep it short and to the point. -5.12. In the year 2004, what is the difference between the Imports(as % of merchandise exports) of East Asia (developing only) and Imports(as % of merchandise exports) of Ecuador?
Your answer should be compact. 4.67. In the year 2004, what is the difference between the Imports(as % of merchandise exports) of East Asia (developing only) and Imports(as % of merchandise exports) of Macao?
Your answer should be compact. 5.32. In the year 2004, what is the difference between the Imports(as % of merchandise exports) in East Asia (developing only) and Imports(as % of merchandise exports) in Norway?
Your response must be concise. -0.2. In the year 2004, what is the difference between the Imports(as % of merchandise exports) in Ecuador and Imports(as % of merchandise exports) in Macao?
Keep it short and to the point. 0.65. In the year 2004, what is the difference between the Imports(as % of merchandise exports) of Ecuador and Imports(as % of merchandise exports) of Norway?
Make the answer very short. -4.87. In the year 2004, what is the difference between the Imports(as % of merchandise exports) of Macao and Imports(as % of merchandise exports) of Norway?
Provide a short and direct response. -5.52. In the year 2005, what is the difference between the Imports(as % of merchandise exports) of East Asia (developing only) and Imports(as % of merchandise exports) of Ecuador?
Provide a succinct answer. 5.45. In the year 2005, what is the difference between the Imports(as % of merchandise exports) in East Asia (developing only) and Imports(as % of merchandise exports) in Macao?
Offer a terse response. 5.99. In the year 2005, what is the difference between the Imports(as % of merchandise exports) of East Asia (developing only) and Imports(as % of merchandise exports) of Norway?
Keep it short and to the point. 0.17. In the year 2005, what is the difference between the Imports(as % of merchandise exports) in Ecuador and Imports(as % of merchandise exports) in Macao?
Offer a very short reply. 0.54. In the year 2005, what is the difference between the Imports(as % of merchandise exports) in Ecuador and Imports(as % of merchandise exports) in Norway?
Your answer should be compact. -5.28. In the year 2005, what is the difference between the Imports(as % of merchandise exports) in Macao and Imports(as % of merchandise exports) in Norway?
Offer a terse response. -5.83. In the year 2006, what is the difference between the Imports(as % of merchandise exports) of East Asia (developing only) and Imports(as % of merchandise exports) of Ecuador?
Your response must be concise. 5.87. In the year 2006, what is the difference between the Imports(as % of merchandise exports) of East Asia (developing only) and Imports(as % of merchandise exports) of Macao?
Make the answer very short. 6.23. In the year 2006, what is the difference between the Imports(as % of merchandise exports) in East Asia (developing only) and Imports(as % of merchandise exports) in Norway?
Give a very brief answer. 0.07. In the year 2006, what is the difference between the Imports(as % of merchandise exports) in Ecuador and Imports(as % of merchandise exports) in Macao?
Provide a short and direct response. 0.36. In the year 2006, what is the difference between the Imports(as % of merchandise exports) in Ecuador and Imports(as % of merchandise exports) in Norway?
Offer a very short reply. -5.8. In the year 2006, what is the difference between the Imports(as % of merchandise exports) of Macao and Imports(as % of merchandise exports) of Norway?
Give a very brief answer. -6.16. In the year 2007, what is the difference between the Imports(as % of merchandise exports) of East Asia (developing only) and Imports(as % of merchandise exports) of Ecuador?
Your answer should be compact. 7.65. In the year 2007, what is the difference between the Imports(as % of merchandise exports) in East Asia (developing only) and Imports(as % of merchandise exports) in Macao?
Offer a terse response. 8.25. In the year 2007, what is the difference between the Imports(as % of merchandise exports) in East Asia (developing only) and Imports(as % of merchandise exports) in Norway?
Your answer should be compact. 0.17. In the year 2007, what is the difference between the Imports(as % of merchandise exports) of Ecuador and Imports(as % of merchandise exports) of Macao?
Your answer should be very brief. 0.6. In the year 2007, what is the difference between the Imports(as % of merchandise exports) in Ecuador and Imports(as % of merchandise exports) in Norway?
Give a very brief answer. -7.48. In the year 2007, what is the difference between the Imports(as % of merchandise exports) of Macao and Imports(as % of merchandise exports) of Norway?
Provide a succinct answer. -8.08. In the year 2008, what is the difference between the Imports(as % of merchandise exports) in East Asia (developing only) and Imports(as % of merchandise exports) in Ecuador?
Provide a succinct answer. 8.71. In the year 2008, what is the difference between the Imports(as % of merchandise exports) of East Asia (developing only) and Imports(as % of merchandise exports) of Macao?
Your answer should be compact. 9.07. In the year 2008, what is the difference between the Imports(as % of merchandise exports) of East Asia (developing only) and Imports(as % of merchandise exports) of Norway?
Offer a very short reply. 2.86. In the year 2008, what is the difference between the Imports(as % of merchandise exports) of Ecuador and Imports(as % of merchandise exports) of Macao?
Keep it short and to the point. 0.36. In the year 2008, what is the difference between the Imports(as % of merchandise exports) of Ecuador and Imports(as % of merchandise exports) of Norway?
Give a very brief answer. -5.85. In the year 2008, what is the difference between the Imports(as % of merchandise exports) in Macao and Imports(as % of merchandise exports) in Norway?
Your response must be concise. -6.21. In the year 2009, what is the difference between the Imports(as % of merchandise exports) in East Asia (developing only) and Imports(as % of merchandise exports) in Ecuador?
Make the answer very short. 8.68. In the year 2009, what is the difference between the Imports(as % of merchandise exports) of East Asia (developing only) and Imports(as % of merchandise exports) of Macao?
Your answer should be very brief. 9.5. In the year 2009, what is the difference between the Imports(as % of merchandise exports) in East Asia (developing only) and Imports(as % of merchandise exports) in Norway?
Ensure brevity in your answer.  5.01. In the year 2009, what is the difference between the Imports(as % of merchandise exports) in Ecuador and Imports(as % of merchandise exports) in Macao?
Give a very brief answer. 0.82. In the year 2009, what is the difference between the Imports(as % of merchandise exports) of Ecuador and Imports(as % of merchandise exports) of Norway?
Your response must be concise. -3.67. In the year 2009, what is the difference between the Imports(as % of merchandise exports) in Macao and Imports(as % of merchandise exports) in Norway?
Your answer should be compact. -4.5. What is the ratio of the Imports(as % of merchandise exports) in East Asia (developing only) in 2002 to that in 2003?
Your response must be concise. 0.96. What is the ratio of the Imports(as % of merchandise exports) of Ecuador in 2002 to that in 2003?
Make the answer very short. 1.16. What is the ratio of the Imports(as % of merchandise exports) in Macao in 2002 to that in 2003?
Keep it short and to the point. 0.83. What is the ratio of the Imports(as % of merchandise exports) of Norway in 2002 to that in 2003?
Make the answer very short. 0.96. What is the ratio of the Imports(as % of merchandise exports) in East Asia (developing only) in 2002 to that in 2004?
Provide a succinct answer. 0.73. What is the ratio of the Imports(as % of merchandise exports) in Ecuador in 2002 to that in 2004?
Provide a succinct answer. 0.99. What is the ratio of the Imports(as % of merchandise exports) of Macao in 2002 to that in 2004?
Provide a short and direct response. 0.54. What is the ratio of the Imports(as % of merchandise exports) of Norway in 2002 to that in 2004?
Your answer should be compact. 0.87. What is the ratio of the Imports(as % of merchandise exports) in East Asia (developing only) in 2002 to that in 2005?
Your answer should be compact. 0.65. What is the ratio of the Imports(as % of merchandise exports) in Ecuador in 2002 to that in 2005?
Offer a very short reply. 1. What is the ratio of the Imports(as % of merchandise exports) in Macao in 2002 to that in 2005?
Provide a succinct answer. 0.46. What is the ratio of the Imports(as % of merchandise exports) in Norway in 2002 to that in 2005?
Keep it short and to the point. 0.81. What is the ratio of the Imports(as % of merchandise exports) in East Asia (developing only) in 2002 to that in 2006?
Offer a terse response. 0.59. What is the ratio of the Imports(as % of merchandise exports) of Ecuador in 2002 to that in 2006?
Your answer should be compact. 0.89. What is the ratio of the Imports(as % of merchandise exports) of Macao in 2002 to that in 2006?
Provide a succinct answer. 0.3. What is the ratio of the Imports(as % of merchandise exports) of Norway in 2002 to that in 2006?
Make the answer very short. 0.74. What is the ratio of the Imports(as % of merchandise exports) of East Asia (developing only) in 2002 to that in 2007?
Your answer should be very brief. 0.47. What is the ratio of the Imports(as % of merchandise exports) in Ecuador in 2002 to that in 2007?
Keep it short and to the point. 0.84. What is the ratio of the Imports(as % of merchandise exports) of Macao in 2002 to that in 2007?
Ensure brevity in your answer.  0.36. What is the ratio of the Imports(as % of merchandise exports) in Norway in 2002 to that in 2007?
Offer a very short reply. 0.59. What is the ratio of the Imports(as % of merchandise exports) in East Asia (developing only) in 2002 to that in 2008?
Your answer should be compact. 0.43. What is the ratio of the Imports(as % of merchandise exports) in Ecuador in 2002 to that in 2008?
Offer a terse response. 1.05. What is the ratio of the Imports(as % of merchandise exports) in Macao in 2002 to that in 2008?
Your response must be concise. 0.38. What is the ratio of the Imports(as % of merchandise exports) of Norway in 2002 to that in 2008?
Offer a very short reply. 0.75. What is the ratio of the Imports(as % of merchandise exports) in East Asia (developing only) in 2002 to that in 2009?
Provide a short and direct response. 0.43. What is the ratio of the Imports(as % of merchandise exports) in Ecuador in 2002 to that in 2009?
Offer a terse response. 0.97. What is the ratio of the Imports(as % of merchandise exports) in Macao in 2002 to that in 2009?
Give a very brief answer. 0.72. What is the ratio of the Imports(as % of merchandise exports) of Norway in 2002 to that in 2009?
Provide a short and direct response. 1.07. What is the ratio of the Imports(as % of merchandise exports) in East Asia (developing only) in 2003 to that in 2004?
Ensure brevity in your answer.  0.76. What is the ratio of the Imports(as % of merchandise exports) in Ecuador in 2003 to that in 2004?
Provide a succinct answer. 0.86. What is the ratio of the Imports(as % of merchandise exports) in Macao in 2003 to that in 2004?
Your response must be concise. 0.64. What is the ratio of the Imports(as % of merchandise exports) of Norway in 2003 to that in 2004?
Your response must be concise. 0.9. What is the ratio of the Imports(as % of merchandise exports) of East Asia (developing only) in 2003 to that in 2005?
Your response must be concise. 0.67. What is the ratio of the Imports(as % of merchandise exports) of Ecuador in 2003 to that in 2005?
Your answer should be compact. 0.86. What is the ratio of the Imports(as % of merchandise exports) in Macao in 2003 to that in 2005?
Ensure brevity in your answer.  0.55. What is the ratio of the Imports(as % of merchandise exports) of Norway in 2003 to that in 2005?
Ensure brevity in your answer.  0.85. What is the ratio of the Imports(as % of merchandise exports) in East Asia (developing only) in 2003 to that in 2006?
Make the answer very short. 0.62. What is the ratio of the Imports(as % of merchandise exports) of Ecuador in 2003 to that in 2006?
Offer a terse response. 0.77. What is the ratio of the Imports(as % of merchandise exports) of Macao in 2003 to that in 2006?
Offer a terse response. 0.36. What is the ratio of the Imports(as % of merchandise exports) in Norway in 2003 to that in 2006?
Ensure brevity in your answer.  0.77. What is the ratio of the Imports(as % of merchandise exports) of East Asia (developing only) in 2003 to that in 2007?
Give a very brief answer. 0.49. What is the ratio of the Imports(as % of merchandise exports) of Ecuador in 2003 to that in 2007?
Your response must be concise. 0.72. What is the ratio of the Imports(as % of merchandise exports) of Macao in 2003 to that in 2007?
Make the answer very short. 0.43. What is the ratio of the Imports(as % of merchandise exports) of Norway in 2003 to that in 2007?
Provide a short and direct response. 0.62. What is the ratio of the Imports(as % of merchandise exports) in East Asia (developing only) in 2003 to that in 2008?
Provide a succinct answer. 0.45. What is the ratio of the Imports(as % of merchandise exports) in Ecuador in 2003 to that in 2008?
Make the answer very short. 0.9. What is the ratio of the Imports(as % of merchandise exports) in Macao in 2003 to that in 2008?
Offer a terse response. 0.45. What is the ratio of the Imports(as % of merchandise exports) of Norway in 2003 to that in 2008?
Provide a short and direct response. 0.78. What is the ratio of the Imports(as % of merchandise exports) in East Asia (developing only) in 2003 to that in 2009?
Provide a succinct answer. 0.45. What is the ratio of the Imports(as % of merchandise exports) of Ecuador in 2003 to that in 2009?
Keep it short and to the point. 0.83. What is the ratio of the Imports(as % of merchandise exports) of Macao in 2003 to that in 2009?
Offer a very short reply. 0.86. What is the ratio of the Imports(as % of merchandise exports) in Norway in 2003 to that in 2009?
Your response must be concise. 1.12. What is the ratio of the Imports(as % of merchandise exports) in East Asia (developing only) in 2004 to that in 2005?
Provide a succinct answer. 0.88. What is the ratio of the Imports(as % of merchandise exports) in Ecuador in 2004 to that in 2005?
Your answer should be compact. 1.01. What is the ratio of the Imports(as % of merchandise exports) of Macao in 2004 to that in 2005?
Your answer should be compact. 0.85. What is the ratio of the Imports(as % of merchandise exports) in Norway in 2004 to that in 2005?
Keep it short and to the point. 0.94. What is the ratio of the Imports(as % of merchandise exports) in East Asia (developing only) in 2004 to that in 2006?
Ensure brevity in your answer.  0.81. What is the ratio of the Imports(as % of merchandise exports) in Ecuador in 2004 to that in 2006?
Provide a short and direct response. 0.9. What is the ratio of the Imports(as % of merchandise exports) in Macao in 2004 to that in 2006?
Your answer should be very brief. 0.56. What is the ratio of the Imports(as % of merchandise exports) of Norway in 2004 to that in 2006?
Provide a succinct answer. 0.85. What is the ratio of the Imports(as % of merchandise exports) in East Asia (developing only) in 2004 to that in 2007?
Your answer should be compact. 0.65. What is the ratio of the Imports(as % of merchandise exports) in Ecuador in 2004 to that in 2007?
Give a very brief answer. 0.84. What is the ratio of the Imports(as % of merchandise exports) of Macao in 2004 to that in 2007?
Provide a succinct answer. 0.67. What is the ratio of the Imports(as % of merchandise exports) in Norway in 2004 to that in 2007?
Your answer should be compact. 0.68. What is the ratio of the Imports(as % of merchandise exports) of East Asia (developing only) in 2004 to that in 2008?
Provide a short and direct response. 0.6. What is the ratio of the Imports(as % of merchandise exports) in Ecuador in 2004 to that in 2008?
Ensure brevity in your answer.  1.06. What is the ratio of the Imports(as % of merchandise exports) of Macao in 2004 to that in 2008?
Offer a terse response. 0.7. What is the ratio of the Imports(as % of merchandise exports) of Norway in 2004 to that in 2008?
Offer a very short reply. 0.87. What is the ratio of the Imports(as % of merchandise exports) of East Asia (developing only) in 2004 to that in 2009?
Give a very brief answer. 0.59. What is the ratio of the Imports(as % of merchandise exports) of Ecuador in 2004 to that in 2009?
Your answer should be compact. 0.97. What is the ratio of the Imports(as % of merchandise exports) in Macao in 2004 to that in 2009?
Provide a succinct answer. 1.34. What is the ratio of the Imports(as % of merchandise exports) in Norway in 2004 to that in 2009?
Make the answer very short. 1.24. What is the ratio of the Imports(as % of merchandise exports) in East Asia (developing only) in 2005 to that in 2006?
Your answer should be very brief. 0.92. What is the ratio of the Imports(as % of merchandise exports) of Ecuador in 2005 to that in 2006?
Offer a terse response. 0.89. What is the ratio of the Imports(as % of merchandise exports) of Macao in 2005 to that in 2006?
Provide a succinct answer. 0.66. What is the ratio of the Imports(as % of merchandise exports) of Norway in 2005 to that in 2006?
Your answer should be compact. 0.91. What is the ratio of the Imports(as % of merchandise exports) in East Asia (developing only) in 2005 to that in 2007?
Offer a terse response. 0.73. What is the ratio of the Imports(as % of merchandise exports) of Ecuador in 2005 to that in 2007?
Your response must be concise. 0.84. What is the ratio of the Imports(as % of merchandise exports) in Macao in 2005 to that in 2007?
Provide a succinct answer. 0.79. What is the ratio of the Imports(as % of merchandise exports) of Norway in 2005 to that in 2007?
Provide a short and direct response. 0.73. What is the ratio of the Imports(as % of merchandise exports) in East Asia (developing only) in 2005 to that in 2008?
Make the answer very short. 0.67. What is the ratio of the Imports(as % of merchandise exports) in Ecuador in 2005 to that in 2008?
Provide a short and direct response. 1.05. What is the ratio of the Imports(as % of merchandise exports) of Macao in 2005 to that in 2008?
Give a very brief answer. 0.83. What is the ratio of the Imports(as % of merchandise exports) of Norway in 2005 to that in 2008?
Offer a very short reply. 0.93. What is the ratio of the Imports(as % of merchandise exports) in East Asia (developing only) in 2005 to that in 2009?
Your answer should be compact. 0.67. What is the ratio of the Imports(as % of merchandise exports) of Ecuador in 2005 to that in 2009?
Offer a very short reply. 0.96. What is the ratio of the Imports(as % of merchandise exports) of Macao in 2005 to that in 2009?
Ensure brevity in your answer.  1.58. What is the ratio of the Imports(as % of merchandise exports) of Norway in 2005 to that in 2009?
Keep it short and to the point. 1.32. What is the ratio of the Imports(as % of merchandise exports) of East Asia (developing only) in 2006 to that in 2007?
Give a very brief answer. 0.79. What is the ratio of the Imports(as % of merchandise exports) in Ecuador in 2006 to that in 2007?
Ensure brevity in your answer.  0.94. What is the ratio of the Imports(as % of merchandise exports) in Macao in 2006 to that in 2007?
Your answer should be compact. 1.2. What is the ratio of the Imports(as % of merchandise exports) in Norway in 2006 to that in 2007?
Give a very brief answer. 0.8. What is the ratio of the Imports(as % of merchandise exports) in East Asia (developing only) in 2006 to that in 2008?
Make the answer very short. 0.73. What is the ratio of the Imports(as % of merchandise exports) in Ecuador in 2006 to that in 2008?
Offer a very short reply. 1.18. What is the ratio of the Imports(as % of merchandise exports) of Macao in 2006 to that in 2008?
Your response must be concise. 1.25. What is the ratio of the Imports(as % of merchandise exports) of Norway in 2006 to that in 2008?
Offer a very short reply. 1.02. What is the ratio of the Imports(as % of merchandise exports) in East Asia (developing only) in 2006 to that in 2009?
Your answer should be very brief. 0.73. What is the ratio of the Imports(as % of merchandise exports) in Ecuador in 2006 to that in 2009?
Give a very brief answer. 1.08. What is the ratio of the Imports(as % of merchandise exports) of Macao in 2006 to that in 2009?
Your answer should be compact. 2.39. What is the ratio of the Imports(as % of merchandise exports) in Norway in 2006 to that in 2009?
Keep it short and to the point. 1.45. What is the ratio of the Imports(as % of merchandise exports) of East Asia (developing only) in 2007 to that in 2008?
Ensure brevity in your answer.  0.92. What is the ratio of the Imports(as % of merchandise exports) of Ecuador in 2007 to that in 2008?
Keep it short and to the point. 1.25. What is the ratio of the Imports(as % of merchandise exports) in Macao in 2007 to that in 2008?
Offer a very short reply. 1.05. What is the ratio of the Imports(as % of merchandise exports) of Norway in 2007 to that in 2008?
Your answer should be very brief. 1.27. What is the ratio of the Imports(as % of merchandise exports) in East Asia (developing only) in 2007 to that in 2009?
Offer a terse response. 0.91. What is the ratio of the Imports(as % of merchandise exports) in Ecuador in 2007 to that in 2009?
Your answer should be very brief. 1.15. What is the ratio of the Imports(as % of merchandise exports) in Macao in 2007 to that in 2009?
Give a very brief answer. 2. What is the ratio of the Imports(as % of merchandise exports) in Norway in 2007 to that in 2009?
Keep it short and to the point. 1.81. What is the ratio of the Imports(as % of merchandise exports) of East Asia (developing only) in 2008 to that in 2009?
Give a very brief answer. 0.99. What is the ratio of the Imports(as % of merchandise exports) in Ecuador in 2008 to that in 2009?
Provide a succinct answer. 0.92. What is the ratio of the Imports(as % of merchandise exports) in Macao in 2008 to that in 2009?
Your answer should be compact. 1.91. What is the ratio of the Imports(as % of merchandise exports) of Norway in 2008 to that in 2009?
Your answer should be very brief. 1.43. What is the difference between the highest and the second highest Imports(as % of merchandise exports) of East Asia (developing only)?
Provide a short and direct response. 0.06. What is the difference between the highest and the second highest Imports(as % of merchandise exports) of Ecuador?
Give a very brief answer. 0.08. What is the difference between the highest and the second highest Imports(as % of merchandise exports) of Macao?
Ensure brevity in your answer.  0.16. What is the difference between the highest and the second highest Imports(as % of merchandise exports) of Norway?
Your answer should be compact. 1.77. What is the difference between the highest and the lowest Imports(as % of merchandise exports) in East Asia (developing only)?
Provide a short and direct response. 5.63. What is the difference between the highest and the lowest Imports(as % of merchandise exports) in Ecuador?
Provide a succinct answer. 0.39. What is the difference between the highest and the lowest Imports(as % of merchandise exports) in Macao?
Offer a terse response. 0.68. What is the difference between the highest and the lowest Imports(as % of merchandise exports) of Norway?
Offer a terse response. 3.99. 